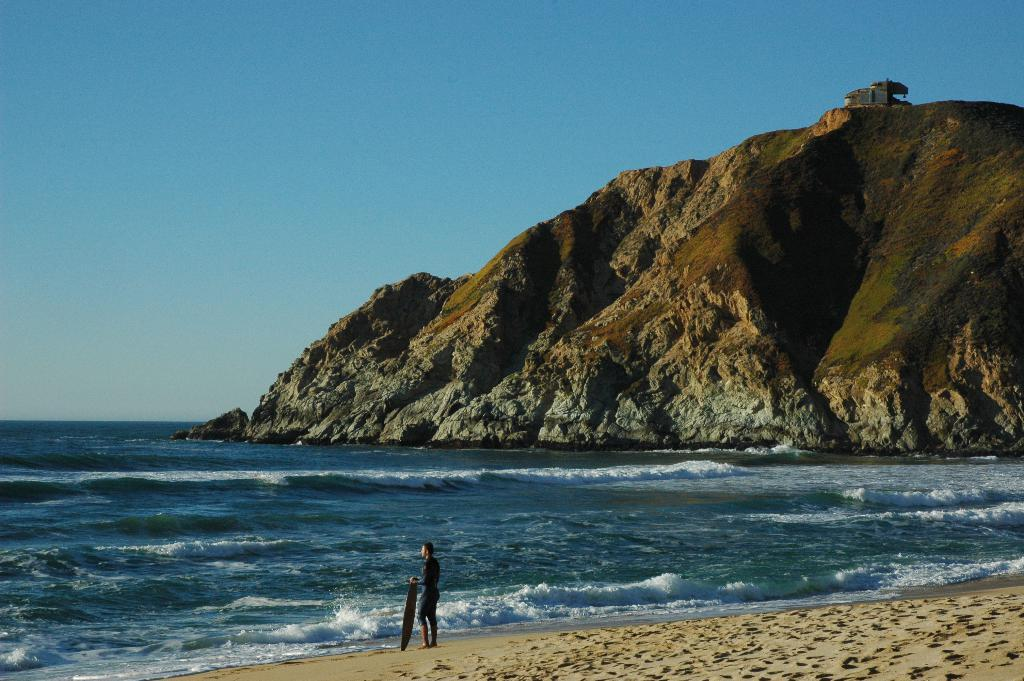What is the person in the image holding? The person is holding a surfboard. What is the setting of the image? There is water visible in the image, suggesting a beach or coastal area. What can be seen in the background of the image? The sky is visible in the background of the image. What other feature is present in the image? There is a hill in the image. What type of berry is being used to make the payment for the surfboard in the image? There is no payment or berry present in the image; the person is simply holding a surfboard. 